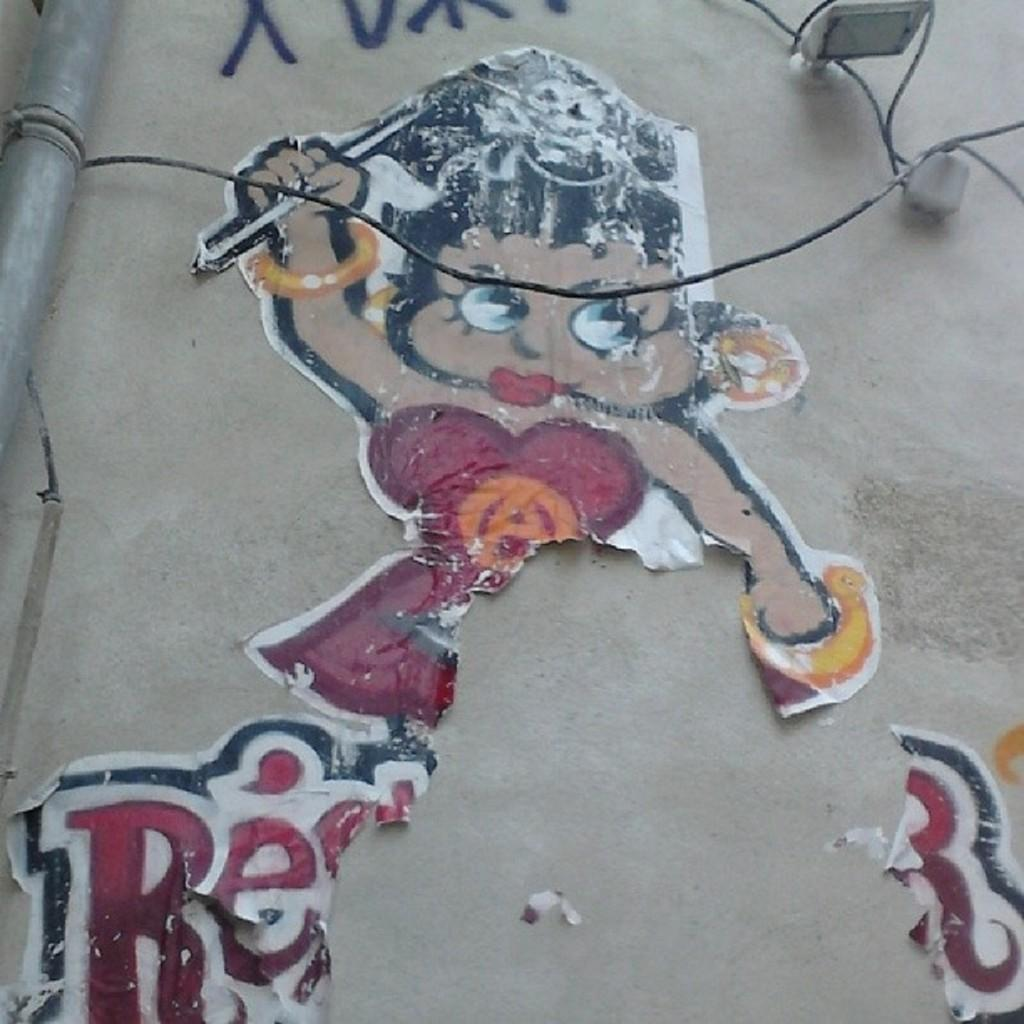What is on the wall in the image? There is a wall with posters in the image. What can be seen on the wall besides the posters? There is text and objects on the wall. What else is present in the image? There is a pole and wires in the image. Can you see a cloud in the image? There is no cloud present in the image. What type of bath is being taken by the objects on the wall? There is no bath or any objects related to bathing in the image. 